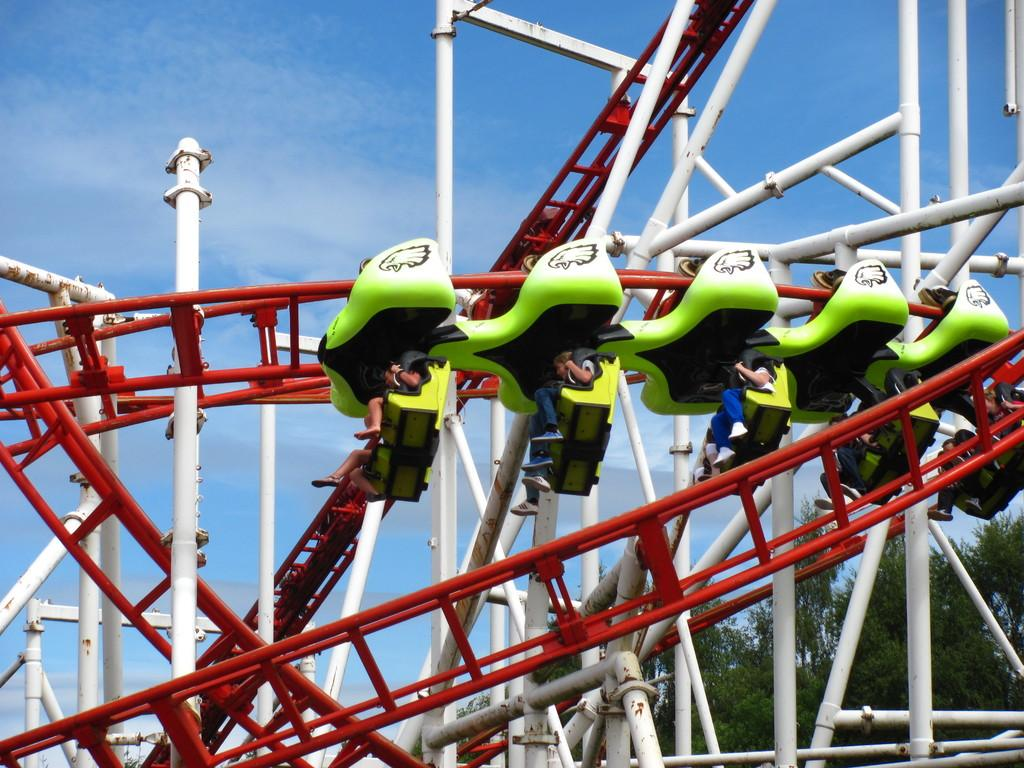What activity are the people in the image participating in? The people in the image are on a roller coaster ride. What can be seen on the right side of the image? There are trees on the right side of the image. What is the color of the sky in the image? The sky is blue in color. How many cats are sitting on the girl's toe in the image? There are no cats or girls present in the image, so this question cannot be answered. 